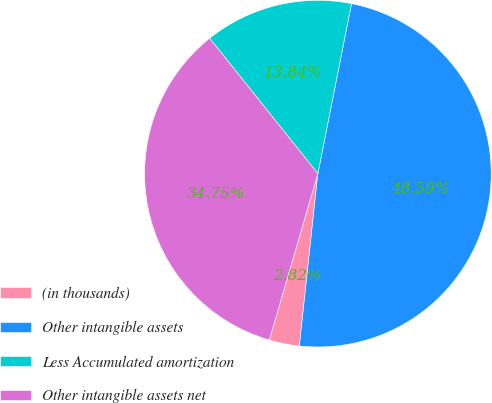Convert chart. <chart><loc_0><loc_0><loc_500><loc_500><pie_chart><fcel>(in thousands)<fcel>Other intangible assets<fcel>Less Accumulated amortization<fcel>Other intangible assets net<nl><fcel>2.82%<fcel>48.59%<fcel>13.84%<fcel>34.75%<nl></chart> 